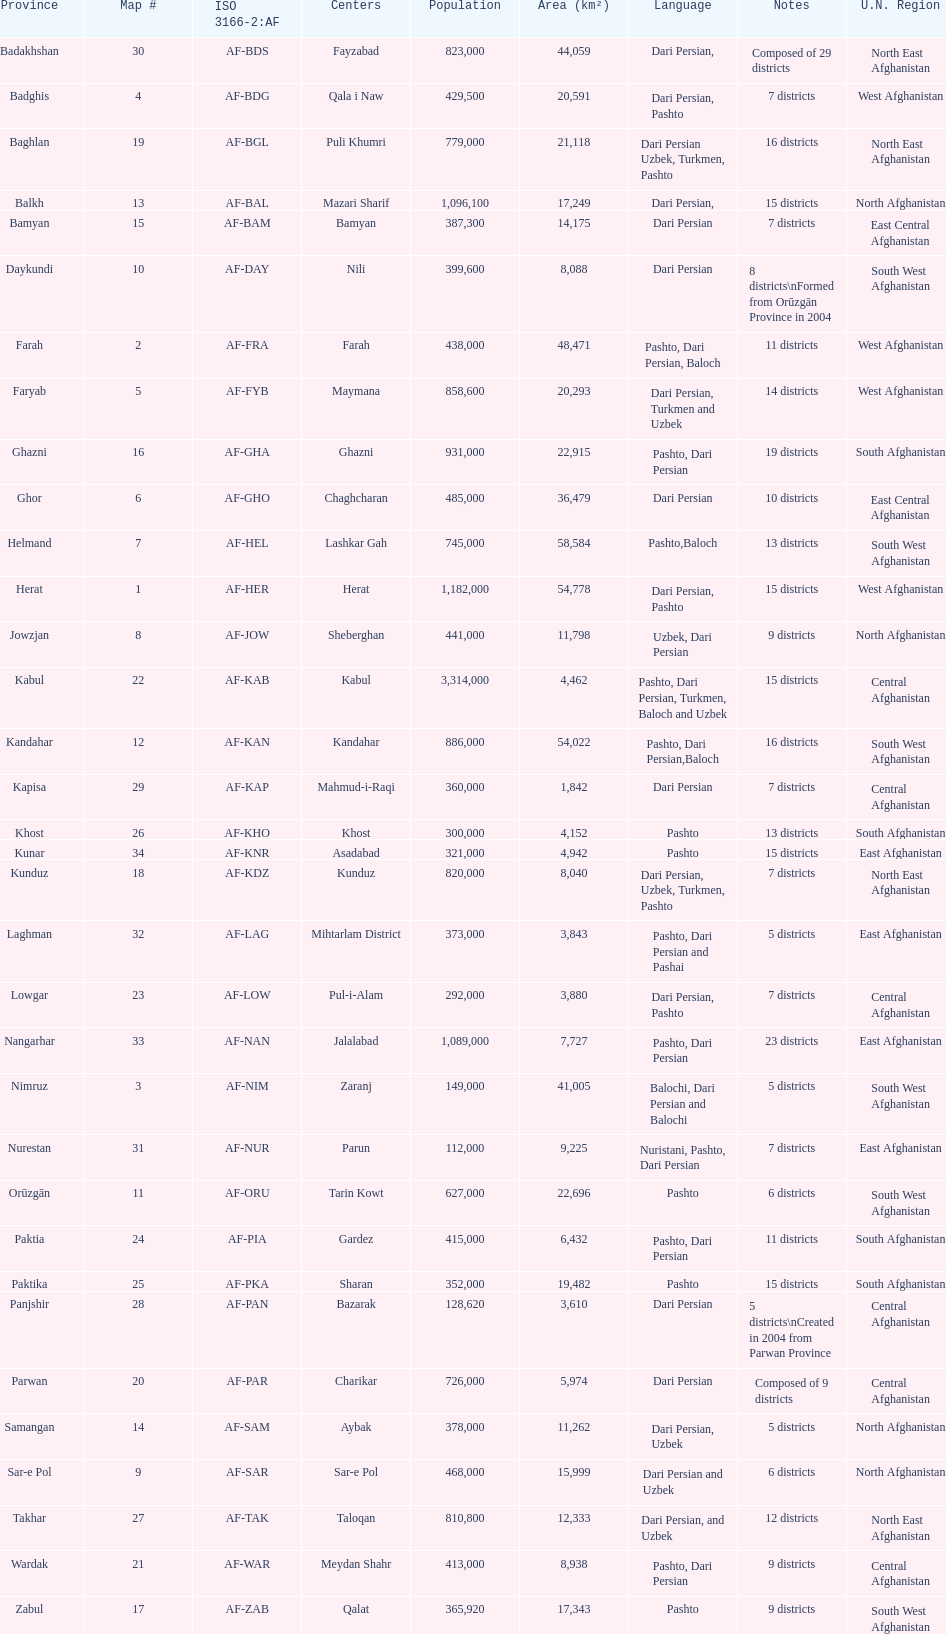In which province is the population the lowest? Nurestan. 